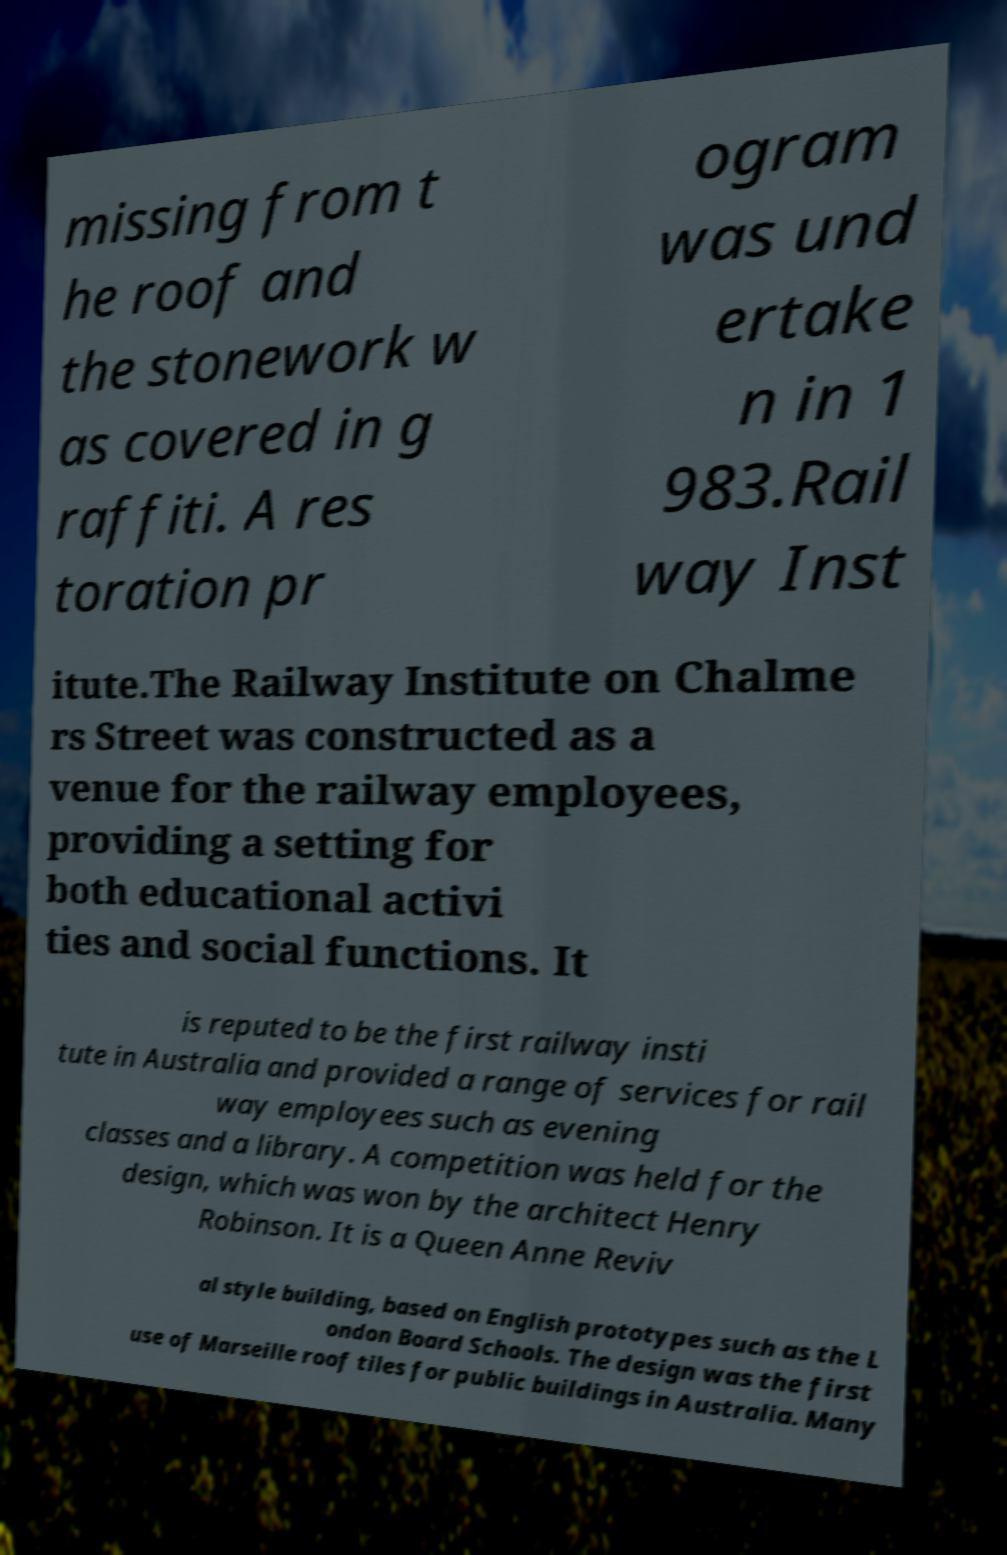I need the written content from this picture converted into text. Can you do that? missing from t he roof and the stonework w as covered in g raffiti. A res toration pr ogram was und ertake n in 1 983.Rail way Inst itute.The Railway Institute on Chalme rs Street was constructed as a venue for the railway employees, providing a setting for both educational activi ties and social functions. It is reputed to be the first railway insti tute in Australia and provided a range of services for rail way employees such as evening classes and a library. A competition was held for the design, which was won by the architect Henry Robinson. It is a Queen Anne Reviv al style building, based on English prototypes such as the L ondon Board Schools. The design was the first use of Marseille roof tiles for public buildings in Australia. Many 